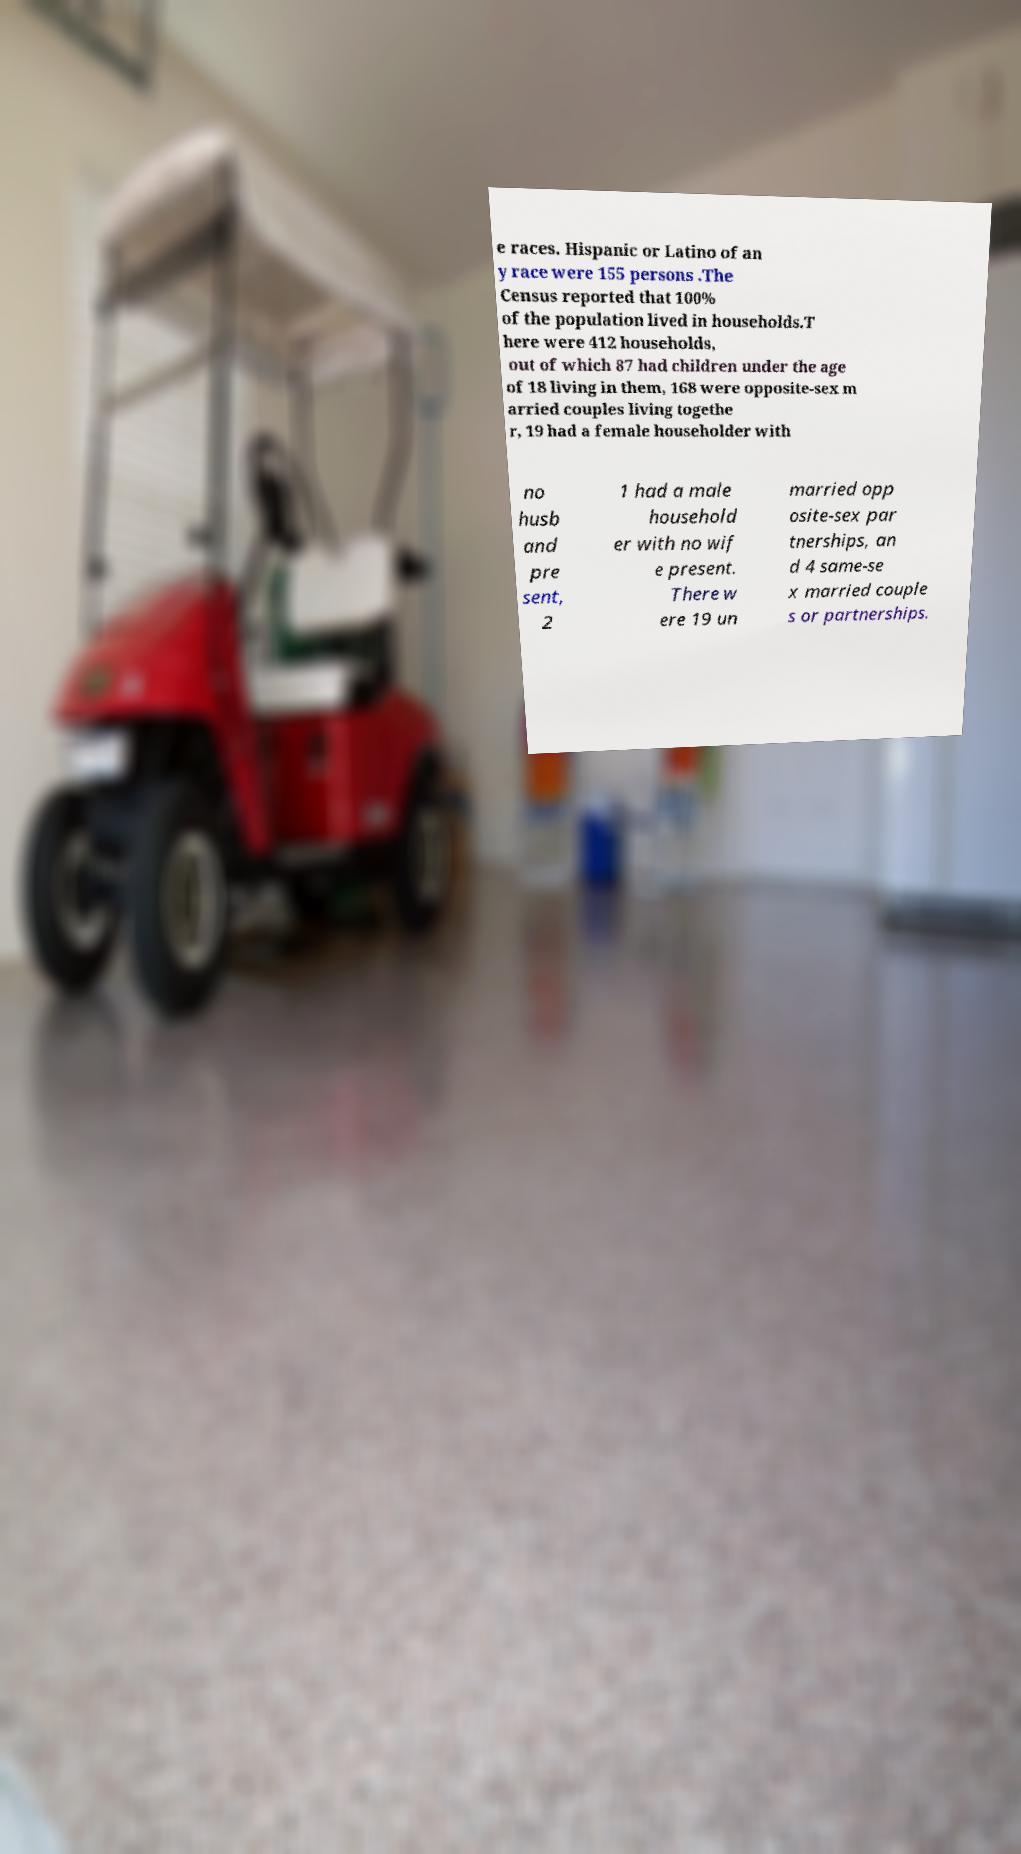Could you assist in decoding the text presented in this image and type it out clearly? e races. Hispanic or Latino of an y race were 155 persons .The Census reported that 100% of the population lived in households.T here were 412 households, out of which 87 had children under the age of 18 living in them, 168 were opposite-sex m arried couples living togethe r, 19 had a female householder with no husb and pre sent, 2 1 had a male household er with no wif e present. There w ere 19 un married opp osite-sex par tnerships, an d 4 same-se x married couple s or partnerships. 